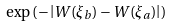Convert formula to latex. <formula><loc_0><loc_0><loc_500><loc_500>\exp \left ( - \left | W ( \xi _ { b } ) - W ( \xi _ { a } ) \right | \right )</formula> 